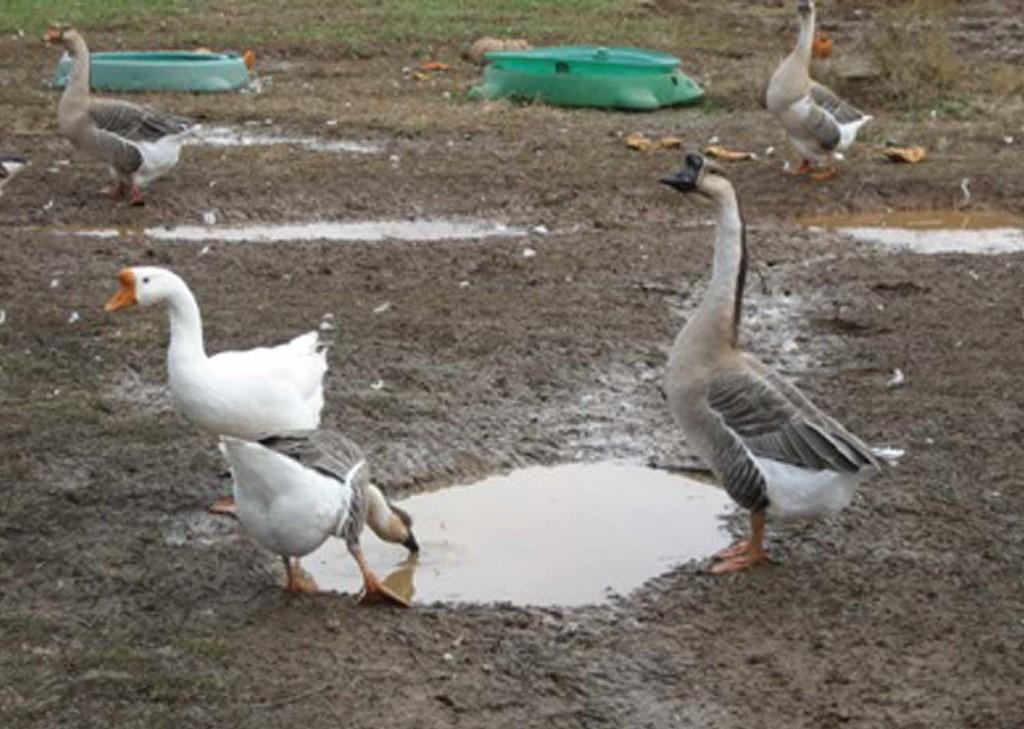What type of animals are present in the image? There are ducks in the image. Where are the ducks located in the image? The ducks are on the ground. Who is the manager of the ducks in the image? There is no indication of a manager or any human presence in the image; it simply features ducks on the ground. 